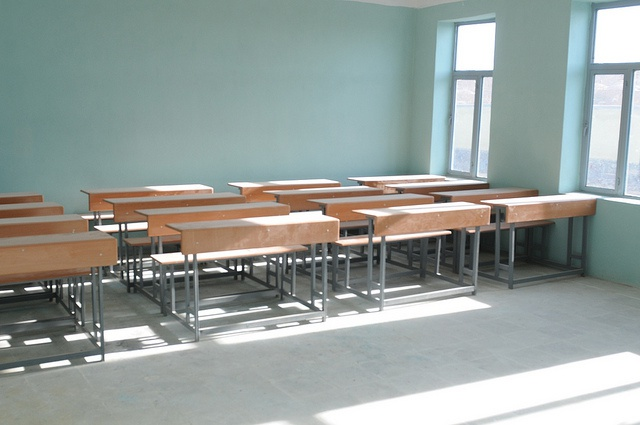Describe the objects in this image and their specific colors. I can see bench in teal, tan, white, gray, and darkgray tones, bench in teal, gray, black, and darkgray tones, bench in teal, gray, white, darkgray, and black tones, bench in teal, brown, and gray tones, and bench in teal, brown, darkgray, and white tones in this image. 